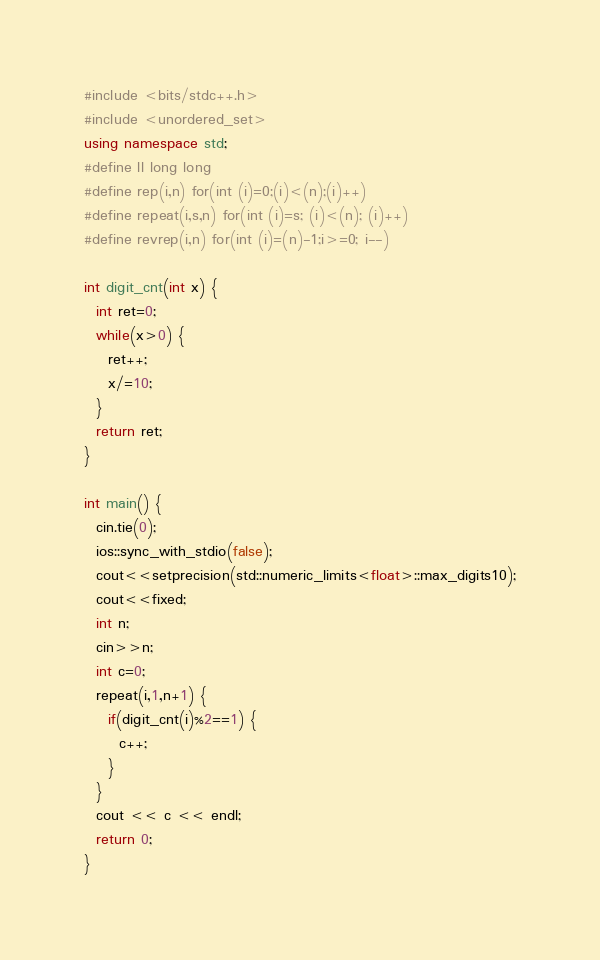<code> <loc_0><loc_0><loc_500><loc_500><_C++_>#include <bits/stdc++.h>
#include <unordered_set>
using namespace std;
#define ll long long
#define rep(i,n) for(int (i)=0;(i)<(n);(i)++)
#define repeat(i,s,n) for(int (i)=s; (i)<(n); (i)++)
#define revrep(i,n) for(int (i)=(n)-1;i>=0; i--)

int digit_cnt(int x) {
  int ret=0;
  while(x>0) {
    ret++;
    x/=10;
  }
  return ret;
}

int main() {
  cin.tie(0);
  ios::sync_with_stdio(false);
  cout<<setprecision(std::numeric_limits<float>::max_digits10);
  cout<<fixed;
  int n;
  cin>>n;
  int c=0;
  repeat(i,1,n+1) {
    if(digit_cnt(i)%2==1) {
      c++;
    }
  }
  cout << c << endl;
  return 0;
}
</code> 